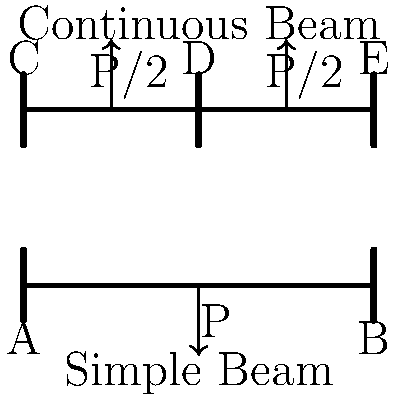As a camel spider enthusiast exploring different habitats, you come across two bridges designed to cross a desert ravine. The first is a simple beam bridge, and the second is a continuous beam bridge with three supports. Both bridges are subjected to the same total load P, but distributed differently as shown in the diagram. Which bridge design would be more suitable for crossing the ravine if you wanted to minimize the maximum bending moment? Let's analyze both bridge designs step-by-step:

1. Simple Beam Bridge:
   - Total span: L
   - Load: P at the center
   - Maximum bending moment: $$M_{max} = \frac{PL}{4}$$

2. Continuous Beam Bridge:
   - Two equal spans: L/2 each
   - Loads: P/2 at the quarter points of the total span
   - For a continuous beam with three supports and symmetrical loading, the maximum bending moment occurs at the supports and mid-spans
   - Maximum bending moment at the central support: $$M_{max} = \frac{PL}{8}$$
   - Maximum bending moment at mid-spans: $$M_{max} = \frac{PL}{32}$$

3. Comparing the maximum bending moments:
   - Simple Beam: $$M_{max} = \frac{PL}{4}$$
   - Continuous Beam: $$M_{max} = \frac{PL}{8}$$ (at the central support)

4. The continuous beam has a lower maximum bending moment:
   $$\frac{PL}{8} < \frac{PL}{4}$$

5. A lower maximum bending moment means:
   - Less stress on the bridge structure
   - Potentially smaller required beam cross-section
   - More efficient use of materials

6. For a camel spider enthusiast exploring desert habitats:
   - The continuous beam design would be more suitable for crossing the ravine
   - It offers better load distribution and lower maximum stress
   - This design could potentially be lighter and more adaptable to the desert environment

Therefore, the continuous beam bridge would be more suitable for crossing the desert ravine while minimizing the maximum bending moment.
Answer: Continuous beam bridge 